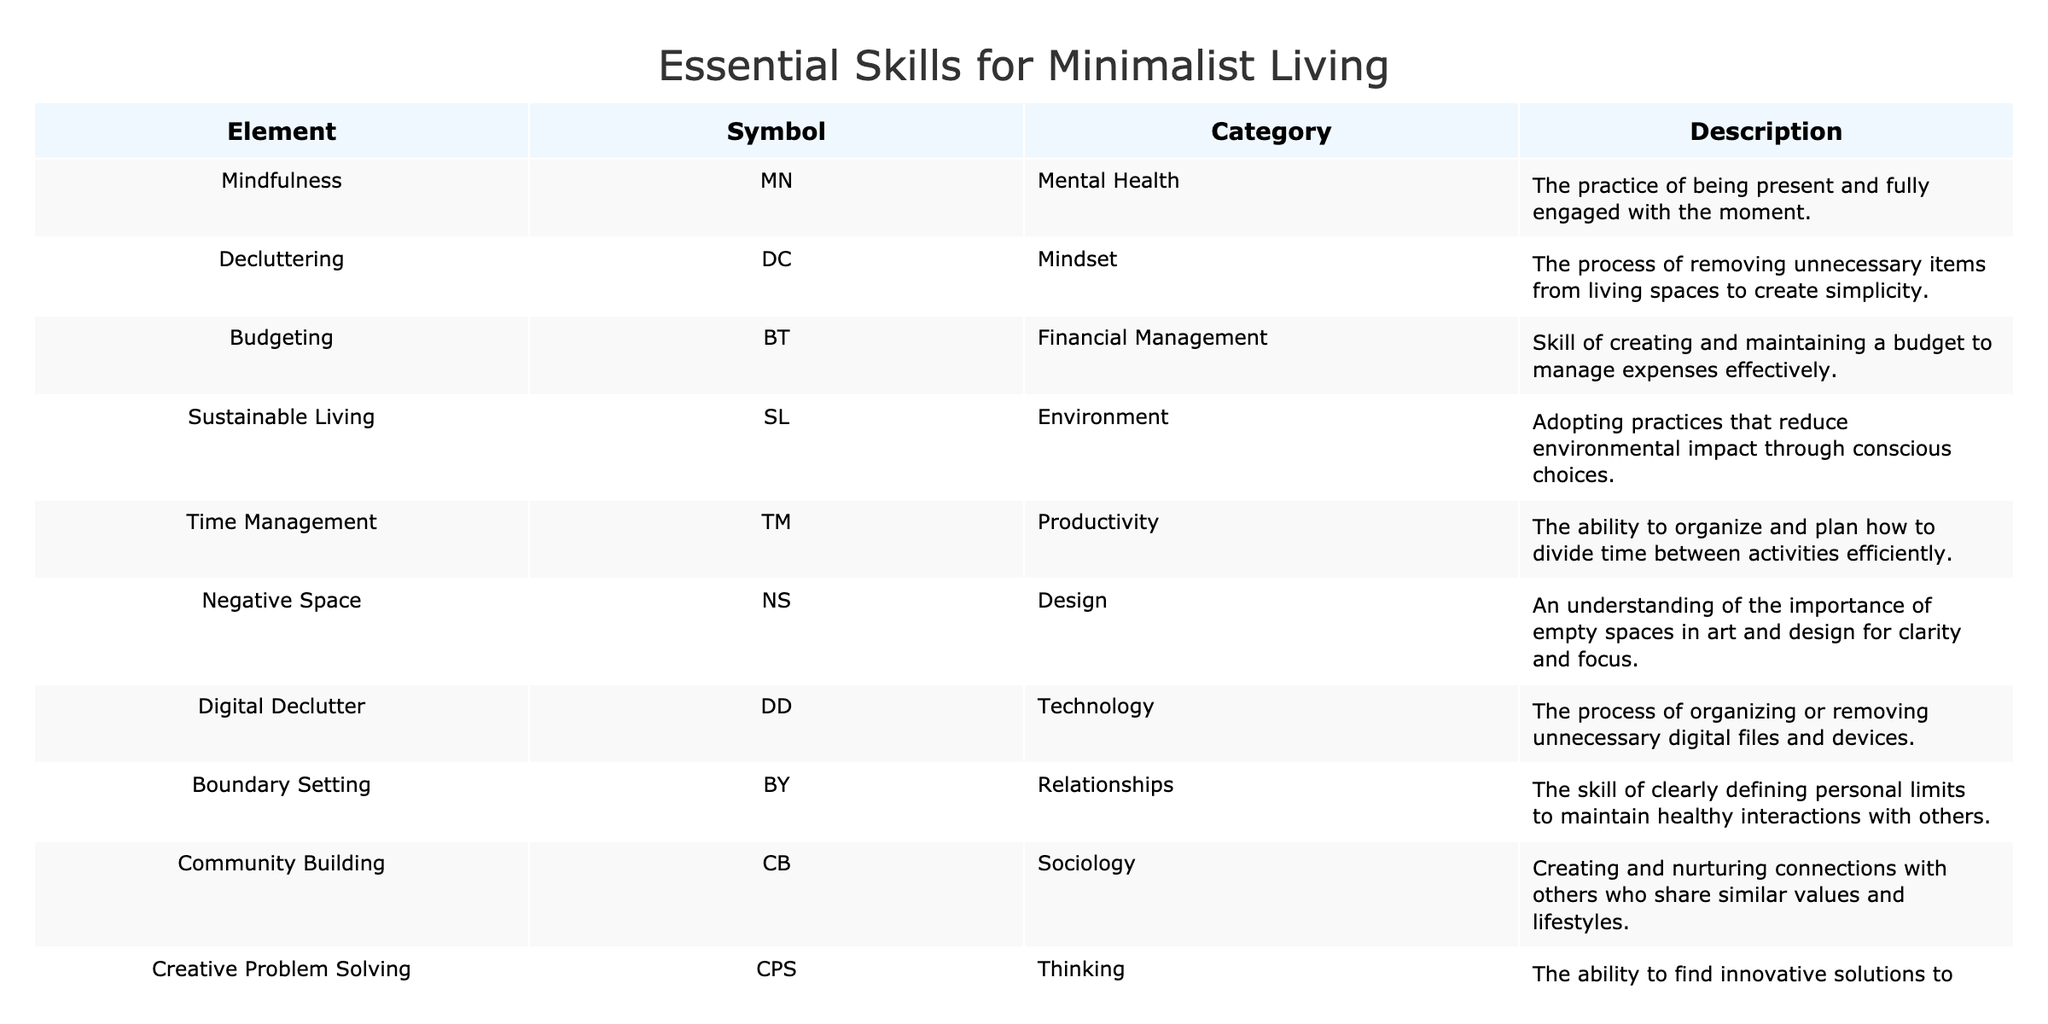What is the symbol for Time Management? The table lists the symbol for Time Management, which is "TM", in the Symbols column.
Answer: TM How many skills are categorized under Relationships? By checking the table, we can see that there is one skill listed under the Relationships category, which is Boundary Setting.
Answer: 1 Which skill focuses on reducing environmental impact? The skill that emphasizes reducing environmental impact is Sustainable Living, as mentioned in the Description column next to the Environment category.
Answer: Sustainable Living Is there a skill aimed specifically at digital organization? Yes, Digital Declutter is aimed specifically at organizing or removing unnecessary digital files and devices. This is confirmed by its entry in the Technology category of the table.
Answer: Yes What is the average number of skills listed per category? There are 11 skills spread across different categories. To calculate the average, we need to find the number of unique categories which is 12. So, the average is calculated as 11 (skills) / 12 (categories) = 0.92.
Answer: 0.92 Which skill in the table relates to clothing? The skill specifically related to clothing is Minimalist Wardrobe, found in the Fashion category. This can be directly referenced from the table.
Answer: Minimalist Wardrobe Does the Mindfulness skill belong to the same category as the Decluttering skill? No, Mindfulness is categorized under Mental Health, while Decluttering is under Mindset. These categories are different and are listed separately in the table.
Answer: No What are the top three categories that have the most associated skills? By reviewing the table, we see that Mental Health and Relationships have one skill each, while all other categories have only one as well. This indicates that there is no clear top three, as all are represented equally.
Answer: None Explain the significance of the skill 'Creative Problem Solving' in minimalist living. The skill 'Creative Problem Solving' is essential for minimizing resources and finding innovative ways to tackle issues. This skill encourages evaluating options more critically in a minimalist context, making it vital for effective living with fewer possessions or distractions.
Answer: Significant 